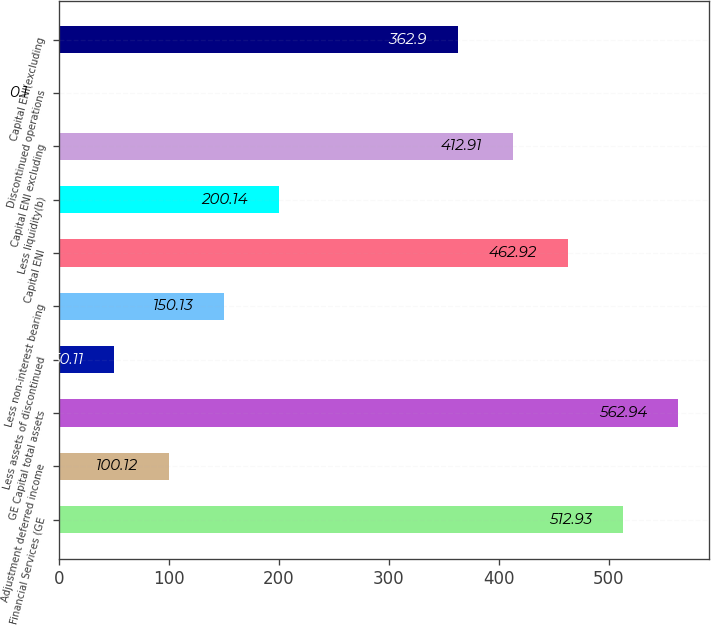Convert chart. <chart><loc_0><loc_0><loc_500><loc_500><bar_chart><fcel>Financial Services (GE<fcel>Adjustment deferred income<fcel>GE Capital total assets<fcel>Less assets of discontinued<fcel>Less non-interest bearing<fcel>Capital ENI<fcel>Less liquidity(b)<fcel>Capital ENI excluding<fcel>Discontinued operations<fcel>Capital ENI(excluding<nl><fcel>512.93<fcel>100.12<fcel>562.94<fcel>50.11<fcel>150.13<fcel>462.92<fcel>200.14<fcel>412.91<fcel>0.1<fcel>362.9<nl></chart> 